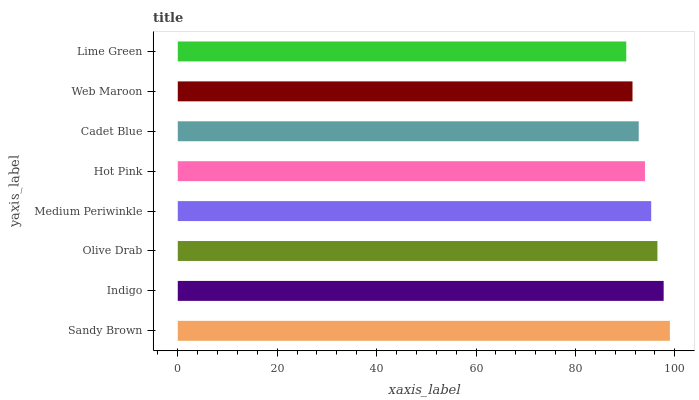Is Lime Green the minimum?
Answer yes or no. Yes. Is Sandy Brown the maximum?
Answer yes or no. Yes. Is Indigo the minimum?
Answer yes or no. No. Is Indigo the maximum?
Answer yes or no. No. Is Sandy Brown greater than Indigo?
Answer yes or no. Yes. Is Indigo less than Sandy Brown?
Answer yes or no. Yes. Is Indigo greater than Sandy Brown?
Answer yes or no. No. Is Sandy Brown less than Indigo?
Answer yes or no. No. Is Medium Periwinkle the high median?
Answer yes or no. Yes. Is Hot Pink the low median?
Answer yes or no. Yes. Is Indigo the high median?
Answer yes or no. No. Is Cadet Blue the low median?
Answer yes or no. No. 